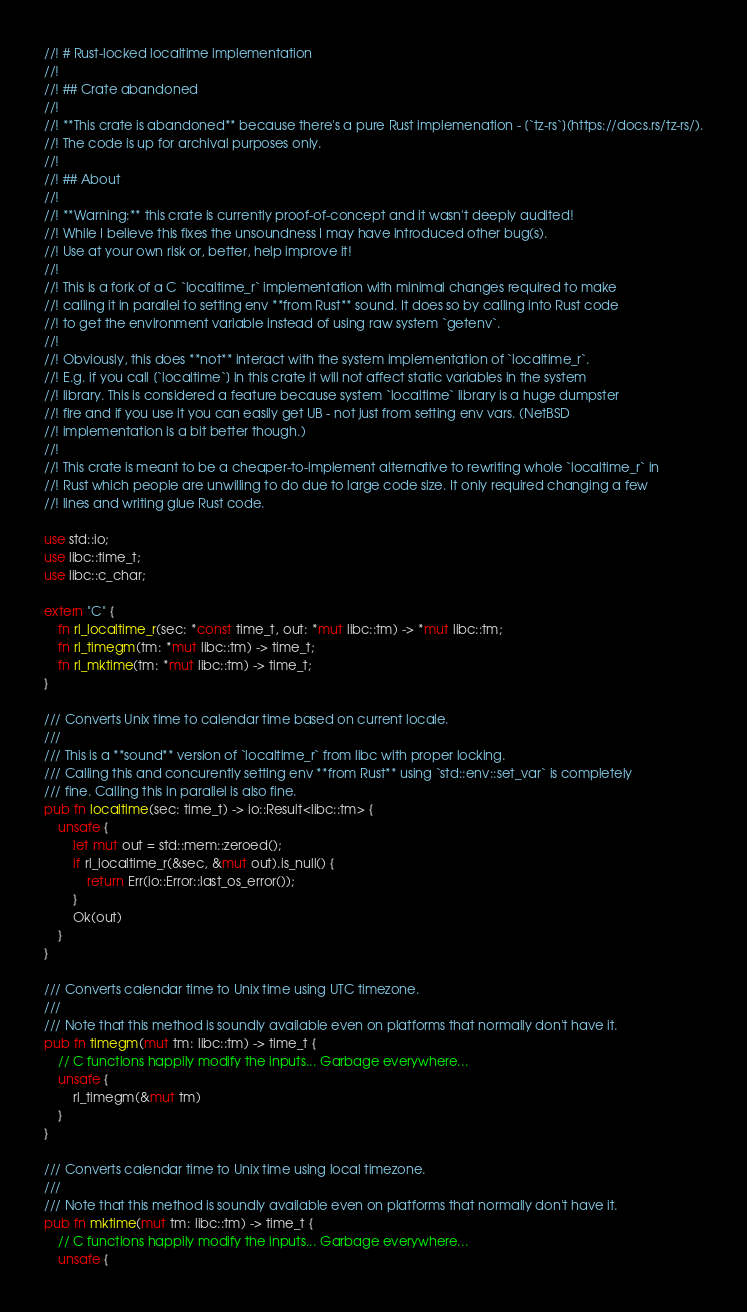Convert code to text. <code><loc_0><loc_0><loc_500><loc_500><_Rust_>//! # Rust-locked localtime implementation
//!
//! ## Crate abandoned
//!
//! **This crate is abandoned** because there's a pure Rust implemenation - [`tz-rs`](https://docs.rs/tz-rs/).
//! The code is up for archival purposes only.
//!
//! ## About
//!
//! **Warning:** this crate is currently proof-of-concept and it wasn't deeply audited!
//! While I believe this fixes the unsoundness I may have introduced other bug(s).
//! Use at your own risk or, better, help improve it!
//!
//! This is a fork of a C `localtime_r` implementation with minimal changes required to make
//! calling it in parallel to setting env **from Rust** sound. It does so by calling into Rust code
//! to get the environment variable instead of using raw system `getenv`.
//!
//! Obviously, this does **not** interact with the system implementation of `localtime_r`.
//! E.g. if you call [`localtime`] in this crate it will not affect static variables in the system
//! library. This is considered a feature because system `localtime` library is a huge dumpster
//! fire and if you use it you can easily get UB - not just from setting env vars. (NetBSD
//! implementation is a bit better though.)
//!
//! This crate is meant to be a cheaper-to-implement alternative to rewriting whole `localtime_r` in
//! Rust which people are unwilling to do due to large code size. It only required changing a few
//! lines and writing glue Rust code.

use std::io;
use libc::time_t;
use libc::c_char;

extern "C" {
    fn rl_localtime_r(sec: *const time_t, out: *mut libc::tm) -> *mut libc::tm;
    fn rl_timegm(tm: *mut libc::tm) -> time_t;
    fn rl_mktime(tm: *mut libc::tm) -> time_t;
}

/// Converts Unix time to calendar time based on current locale.
///
/// This is a **sound** version of `localtime_r` from libc with proper locking.
/// Calling this and concurently setting env **from Rust** using `std::env::set_var` is completely
/// fine. Calling this in parallel is also fine.
pub fn localtime(sec: time_t) -> io::Result<libc::tm> {
    unsafe {
        let mut out = std::mem::zeroed();
        if rl_localtime_r(&sec, &mut out).is_null() {
            return Err(io::Error::last_os_error());
        }
        Ok(out)
    }
}

/// Converts calendar time to Unix time using UTC timezone.
///
/// Note that this method is soundly available even on platforms that normally don't have it.
pub fn timegm(mut tm: libc::tm) -> time_t {
    // C functions happily modify the inputs... Garbage everywhere...
    unsafe {
        rl_timegm(&mut tm)
    }
}

/// Converts calendar time to Unix time using local timezone.
///
/// Note that this method is soundly available even on platforms that normally don't have it.
pub fn mktime(mut tm: libc::tm) -> time_t {
    // C functions happily modify the inputs... Garbage everywhere...
    unsafe {</code> 